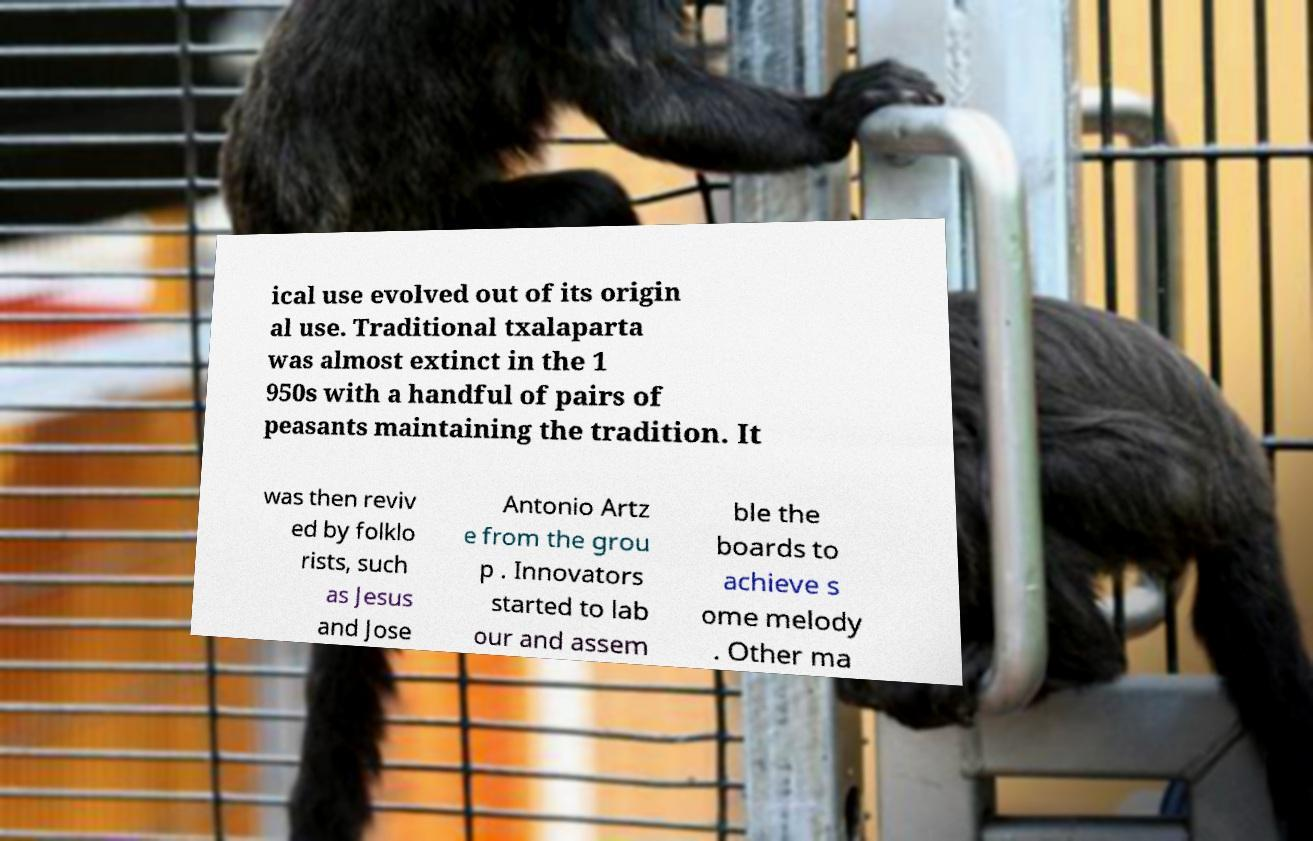Please read and relay the text visible in this image. What does it say? ical use evolved out of its origin al use. Traditional txalaparta was almost extinct in the 1 950s with a handful of pairs of peasants maintaining the tradition. It was then reviv ed by folklo rists, such as Jesus and Jose Antonio Artz e from the grou p . Innovators started to lab our and assem ble the boards to achieve s ome melody . Other ma 